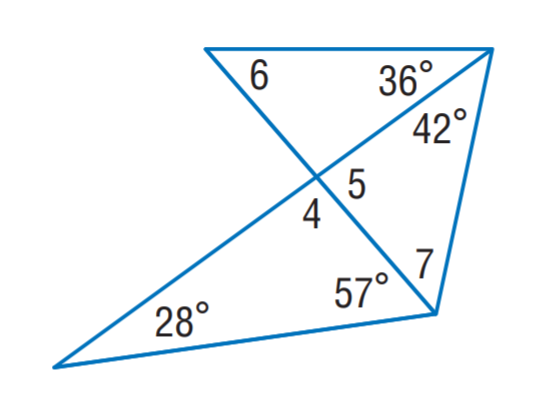Answer the mathemtical geometry problem and directly provide the correct option letter.
Question: Find m \angle 4.
Choices: A: 53 B: 85 C: 95 D: 100 C 